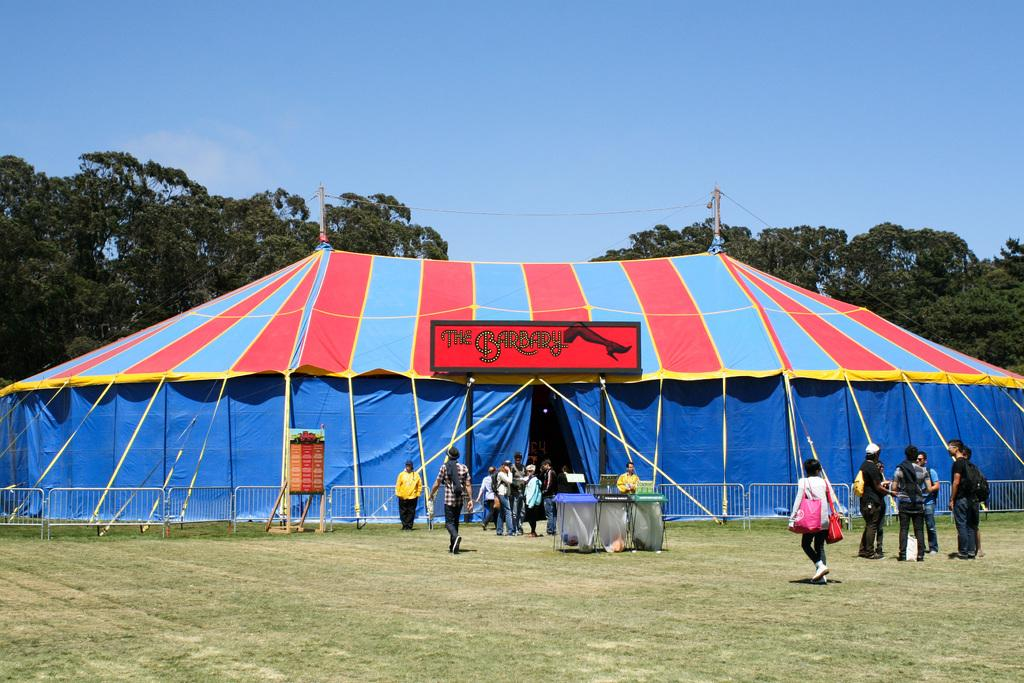What type of vegetation is present on the ground in the image? There is grass on the ground in the image. What can be seen in the image besides the grass? There are people standing and a tent visible in the image. What type of trees are present in the image? There are green color trees in the image. What color is the sky in the image? The sky is blue in the image. Can you see a harbor with boats in the image? No, there is no harbor or boats present in the image. What type of toad can be seen in the image? There is no toad present in the image. 